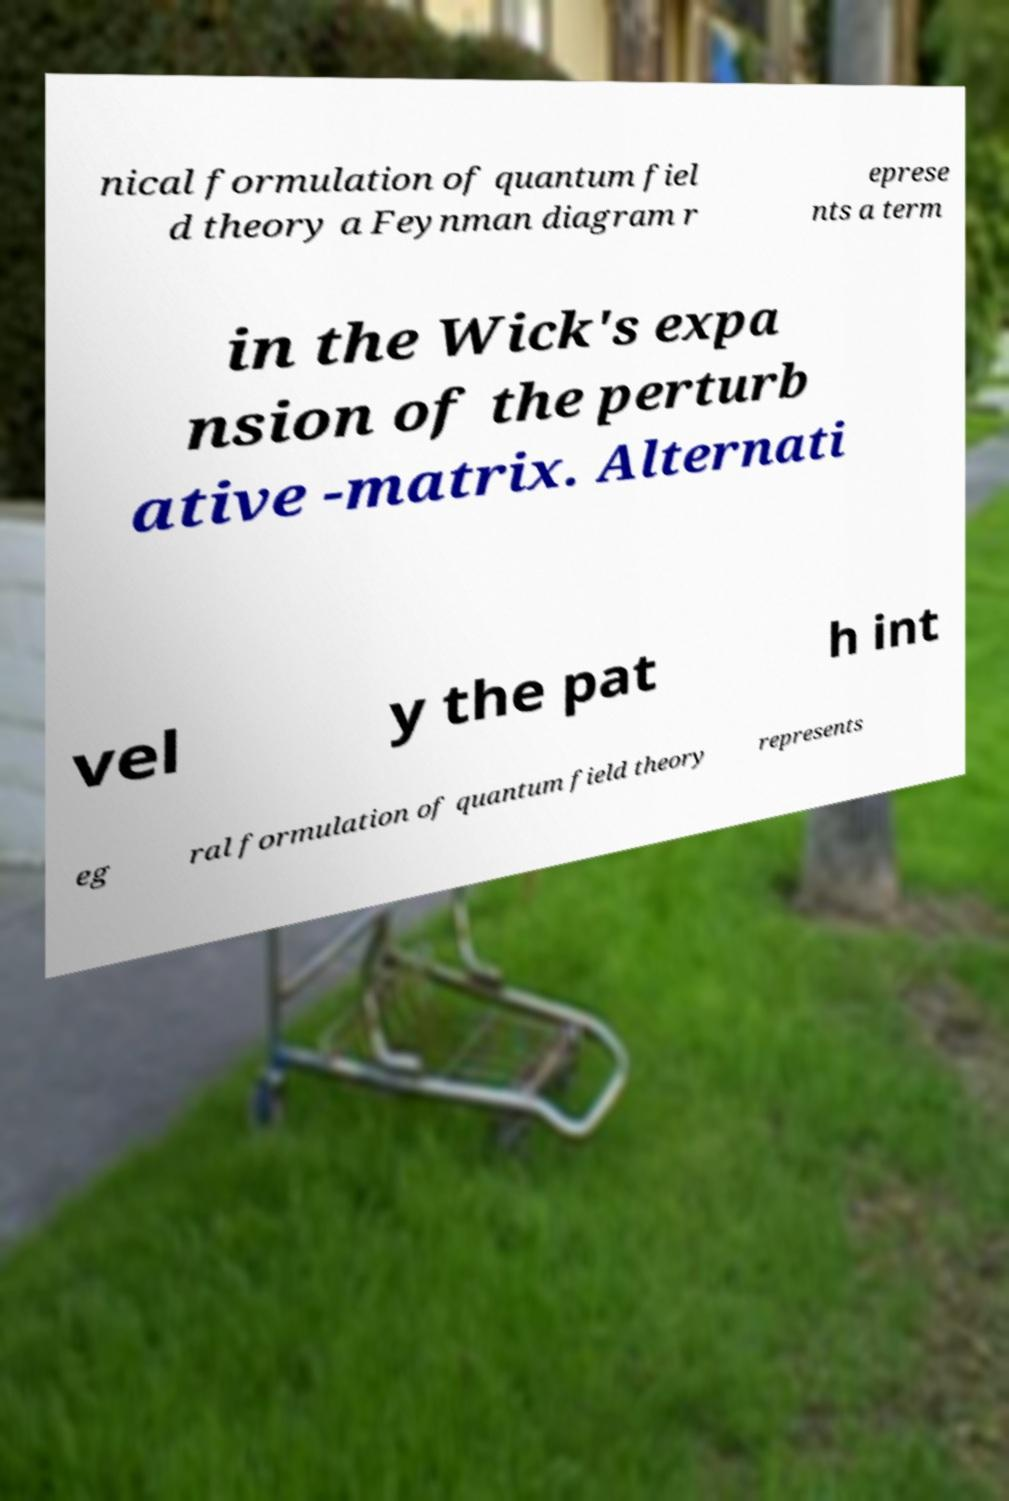What messages or text are displayed in this image? I need them in a readable, typed format. nical formulation of quantum fiel d theory a Feynman diagram r eprese nts a term in the Wick's expa nsion of the perturb ative -matrix. Alternati vel y the pat h int eg ral formulation of quantum field theory represents 